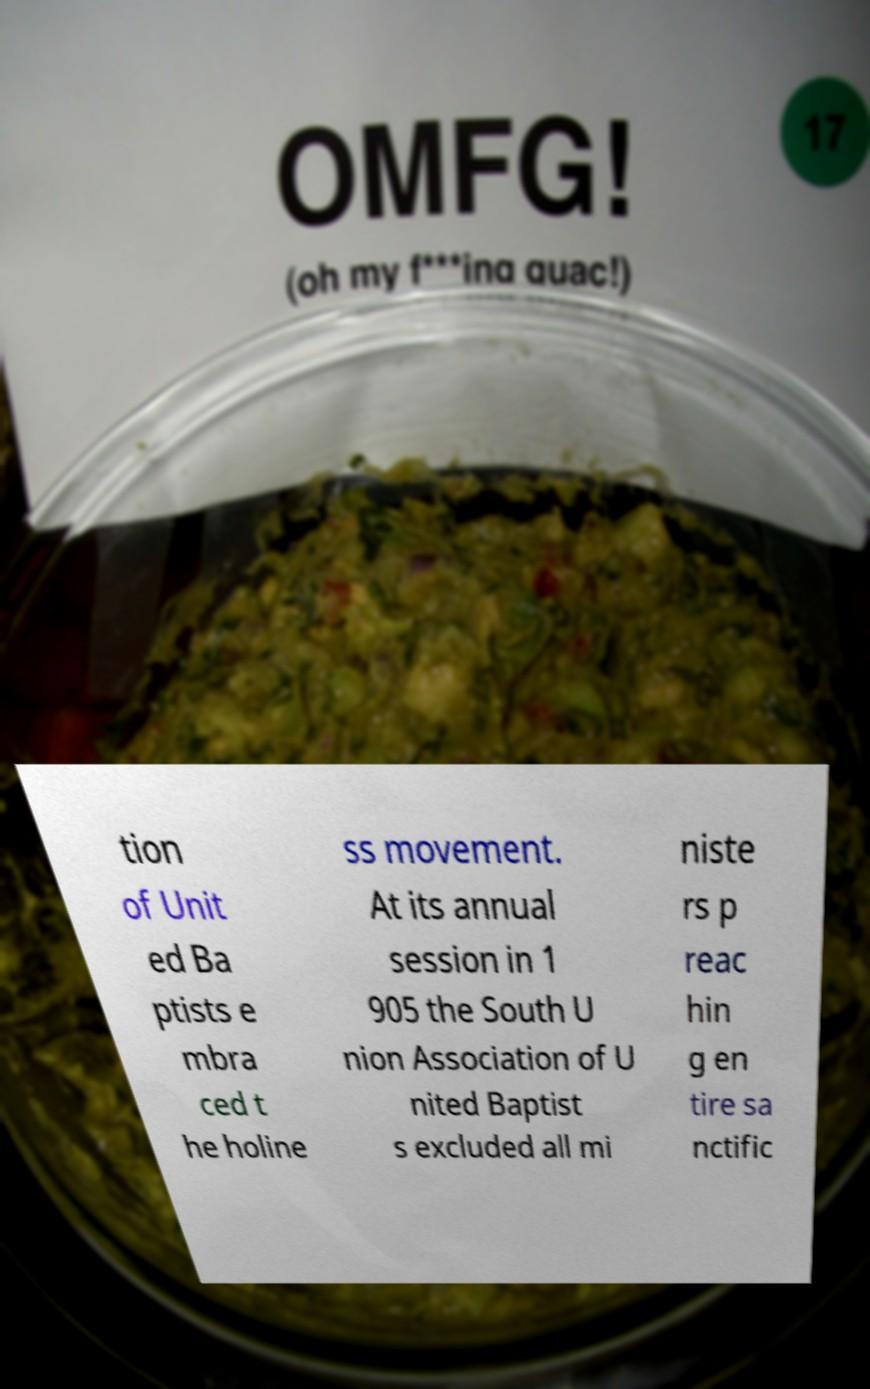There's text embedded in this image that I need extracted. Can you transcribe it verbatim? tion of Unit ed Ba ptists e mbra ced t he holine ss movement. At its annual session in 1 905 the South U nion Association of U nited Baptist s excluded all mi niste rs p reac hin g en tire sa nctific 